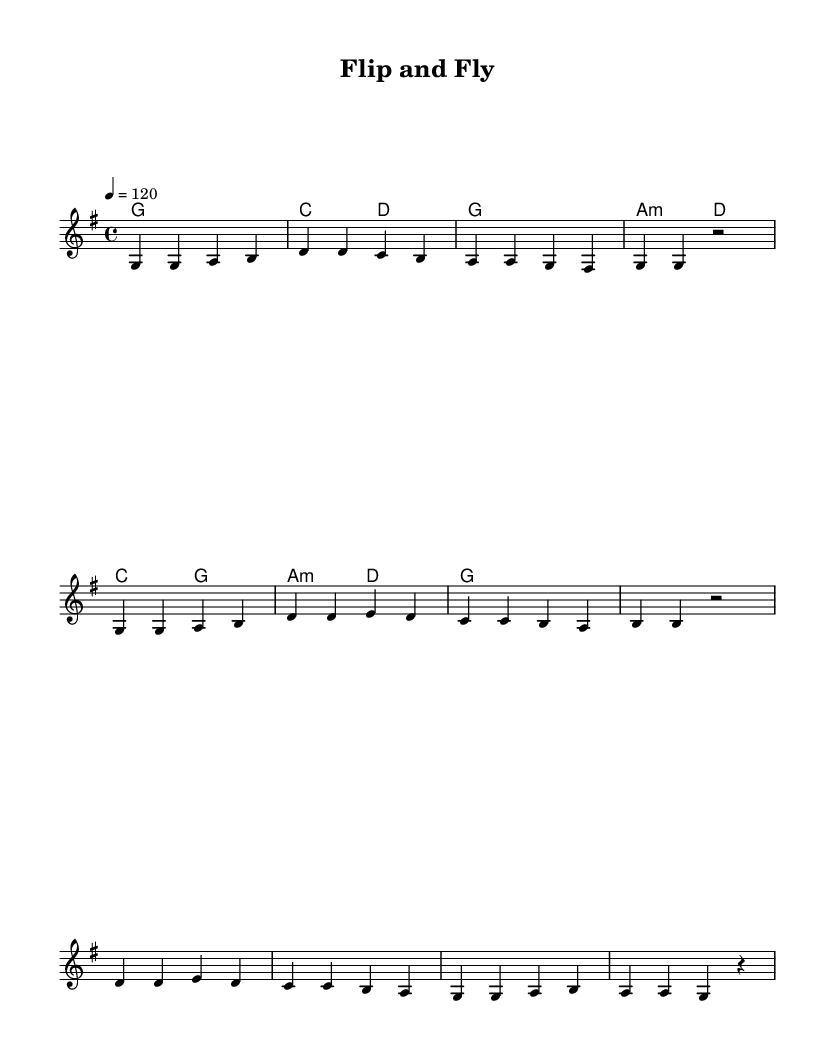What is the key signature of this music? The key signature is indicated at the beginning of the score and reflects the number of sharps or flats. Here, it shows one sharp (F#), which corresponds to G major.
Answer: G major What is the time signature of this music? The time signature is found at the beginning of the score, indicating how many beats are in each measure. In this case, it indicates four beats per measure, which is represented as 4/4.
Answer: 4/4 What is the tempo marking for this piece? The tempo is specified in beats per minute at the start of the score. Here it indicates a tempo of 120 beats per minute.
Answer: 120 How many bars are in the melody section? To find the number of bars, we count the individual measures in the melody line from start to finish. The melody has a total of 8 measures.
Answer: 8 What is the main emotion conveyed in the chorus lyrics? The chorus lyrics express feelings of aspiration and support among teammates, reflecting joyous and uplifting emotions related to performance and success. The repeated phrase "We flip and fly" emphasizes this.
Answer: Uplifting What chords are used in the harmonies section? The chords listed in the chord mode section consist of G major, C major, D major, and A minor. We can identify these by their notation following the chord names.
Answer: G, C, D, A minor How does the first line of the verse relate to gymnastics? The first line refers to “Chalk on our hands, nerves in our hearts,” which connects directly to the physical and emotional preparation gymnasts experience while competing. Chalk is commonly used for grip, reflecting the sport's context.
Answer: Preparation 